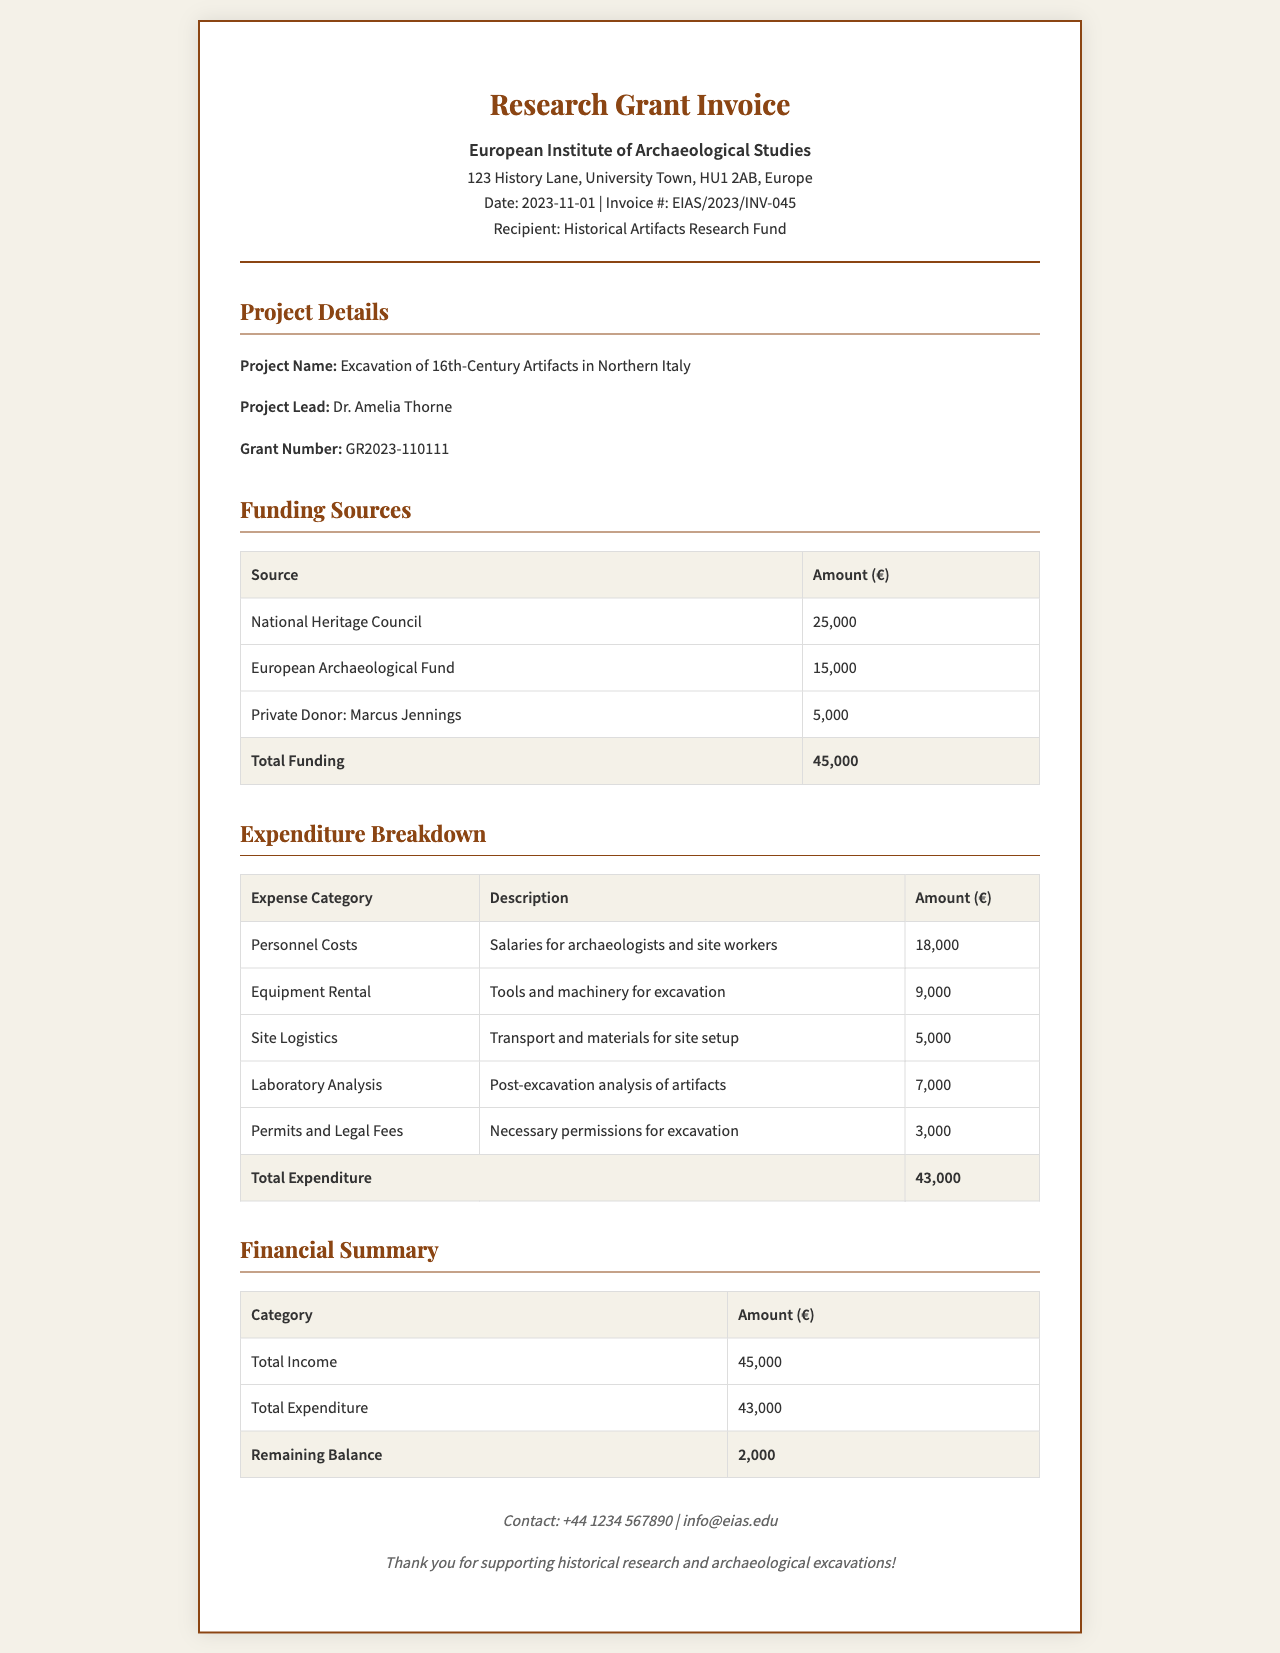what is the project name? The project name is mentioned in the project details section of the document.
Answer: Excavation of 16th-Century Artifacts in Northern Italy who is the project lead? The project lead's name is provided in the project details section.
Answer: Dr. Amelia Thorne what is the total funding amount? The total funding is calculated from all funding sources listed in the document.
Answer: 45,000 what is the total expenditure? The total expenditure is provided in the expenditure breakdown section, summarizing all expenses.
Answer: 43,000 how much is allocated for personnel costs? The personnel costs are specified in the expenditure breakdown under that category.
Answer: 18,000 what is the remaining balance after expenditures? The remaining balance is calculated as total funding minus total expenditure, which is stated in the financial summary.
Answer: 2,000 which organization provided the most funding? The funding source with the highest amount is noted in the funding sources table.
Answer: National Heritage Council what is the grant number? The grant number is specified in the project details section.
Answer: GR2023-110111 how much was spent on permits and legal fees? The expense for permits and legal fees is listed in the expenditure breakdown table.
Answer: 3,000 